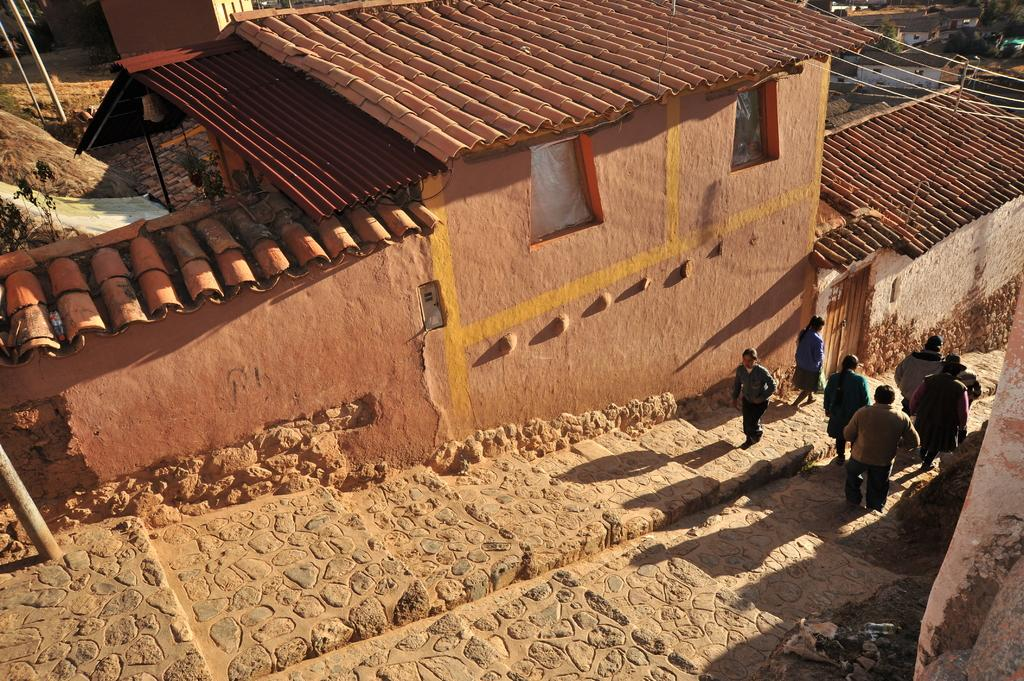What are the people in the image doing? The people in the image are on the stairs. What can be seen in the background of the image? There are houses, poles with wires, trees, and plants in the background of the image. What type of thought can be seen in the image? There are no thoughts visible in the image, as thoughts are not something that can be seen. Can you tell me how many cups are arranged on the stairs in the image? There are no cups present in the image. 